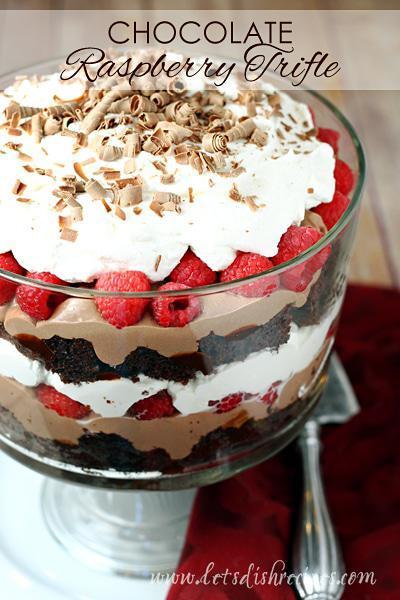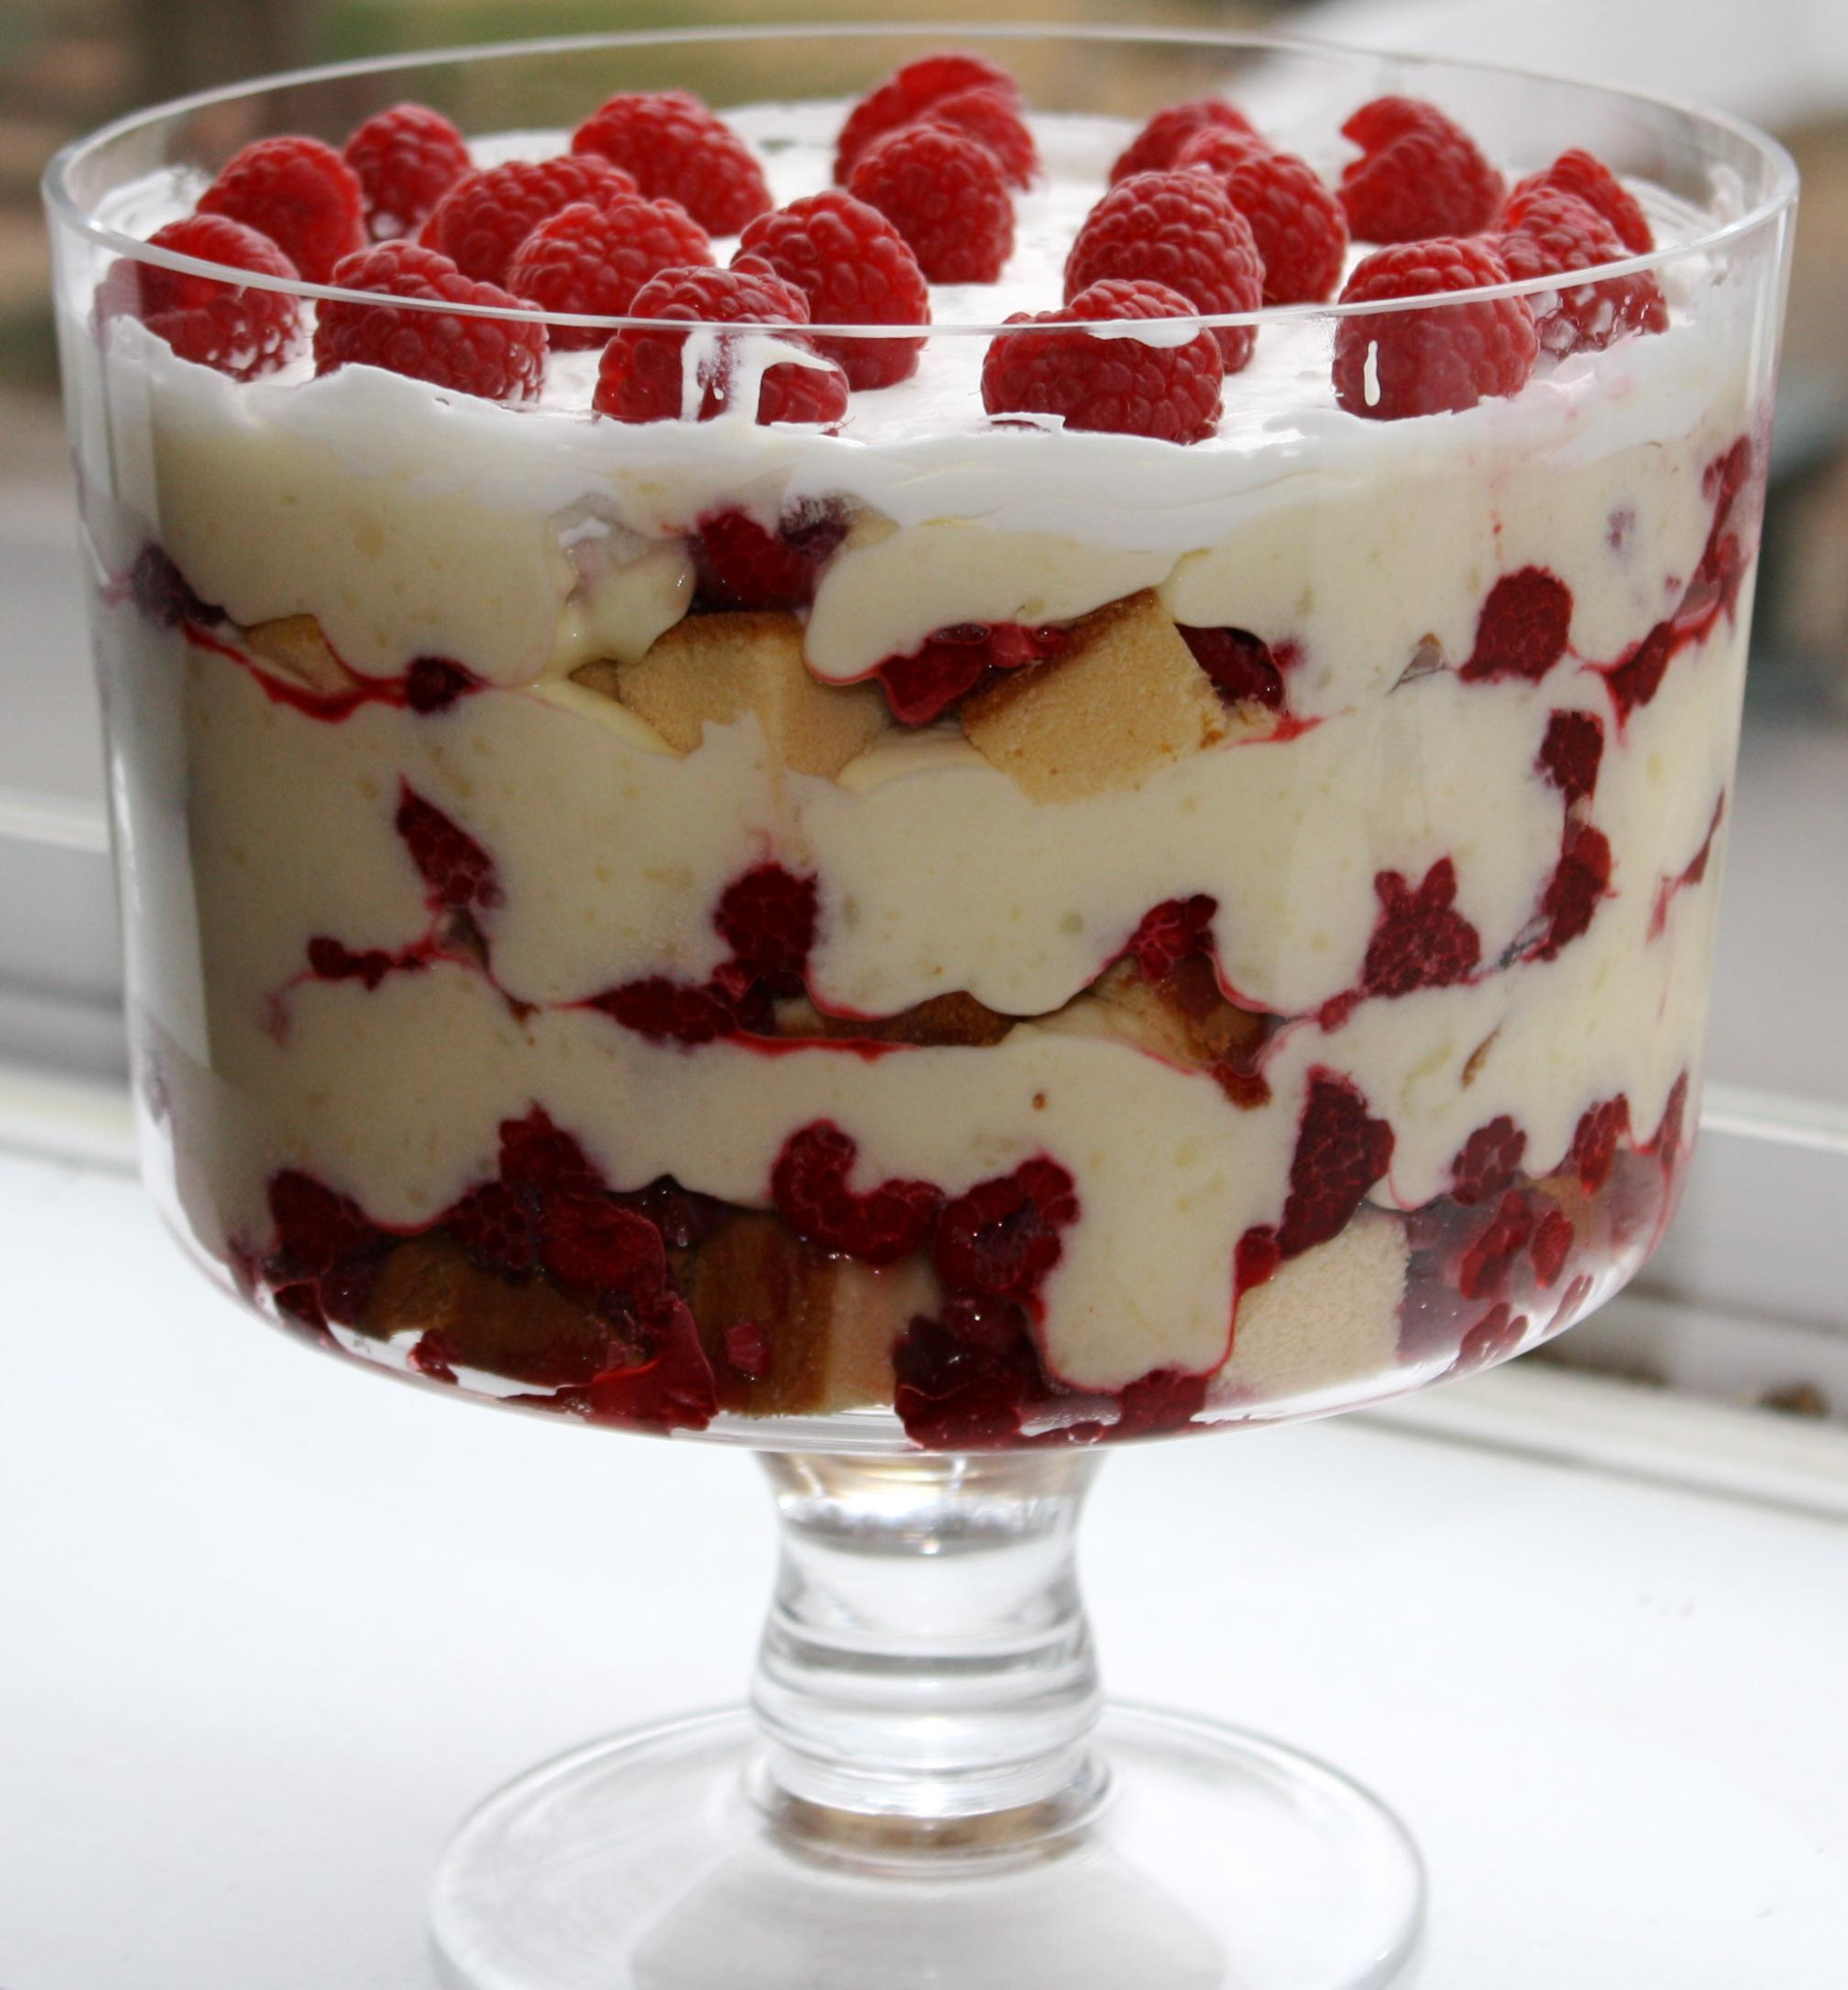The first image is the image on the left, the second image is the image on the right. For the images shown, is this caption "There is a silver utensil next to a trifle." true? Answer yes or no. Yes. The first image is the image on the left, the second image is the image on the right. Given the left and right images, does the statement "An image shows one large dessert in a footed glass, garnished with raspberries on top and not any form of chocolate." hold true? Answer yes or no. Yes. 